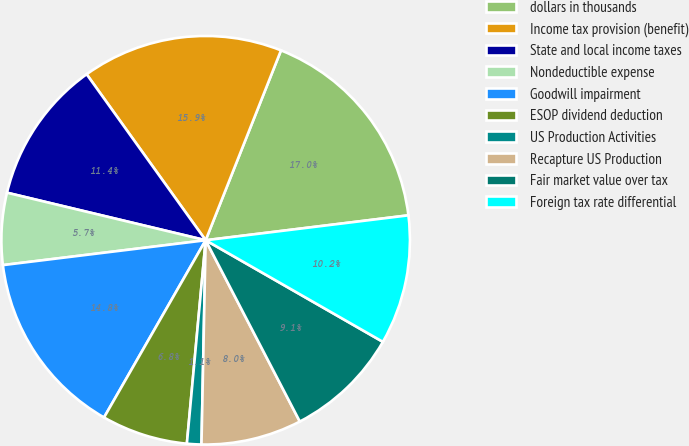<chart> <loc_0><loc_0><loc_500><loc_500><pie_chart><fcel>dollars in thousands<fcel>Income tax provision (benefit)<fcel>State and local income taxes<fcel>Nondeductible expense<fcel>Goodwill impairment<fcel>ESOP dividend deduction<fcel>US Production Activities<fcel>Recapture US Production<fcel>Fair market value over tax<fcel>Foreign tax rate differential<nl><fcel>17.04%<fcel>15.91%<fcel>11.36%<fcel>5.68%<fcel>14.77%<fcel>6.82%<fcel>1.14%<fcel>7.95%<fcel>9.09%<fcel>10.23%<nl></chart> 